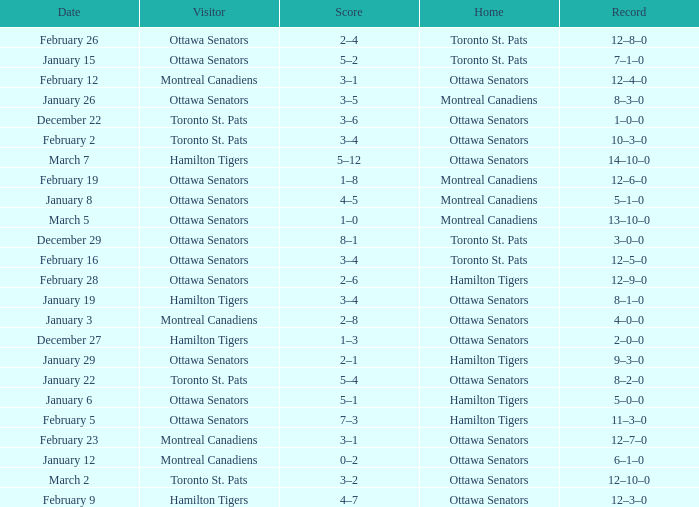What is the record for the game on January 19? 8–1–0. 